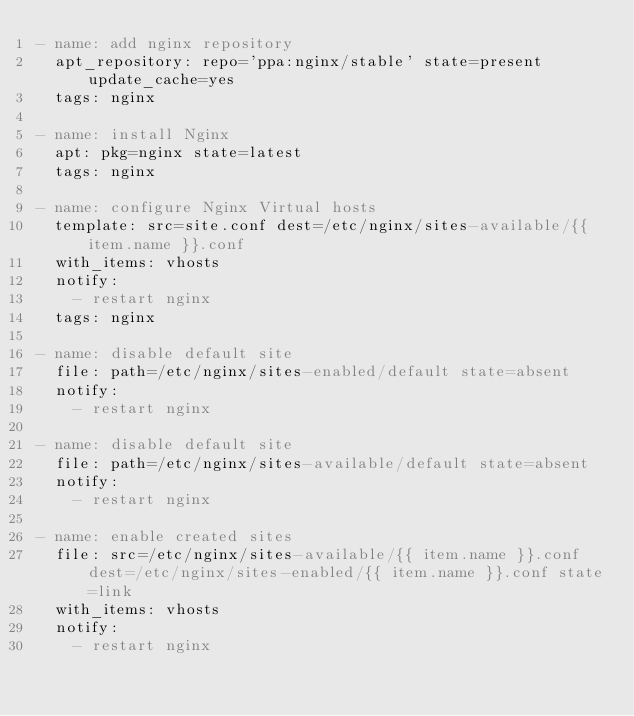Convert code to text. <code><loc_0><loc_0><loc_500><loc_500><_YAML_>- name: add nginx repository
  apt_repository: repo='ppa:nginx/stable' state=present update_cache=yes
  tags: nginx

- name: install Nginx
  apt: pkg=nginx state=latest
  tags: nginx

- name: configure Nginx Virtual hosts
  template: src=site.conf dest=/etc/nginx/sites-available/{{ item.name }}.conf
  with_items: vhosts
  notify:
    - restart nginx
  tags: nginx

- name: disable default site
  file: path=/etc/nginx/sites-enabled/default state=absent
  notify:
    - restart nginx
    
- name: disable default site
  file: path=/etc/nginx/sites-available/default state=absent
  notify:
    - restart nginx

- name: enable created sites
  file: src=/etc/nginx/sites-available/{{ item.name }}.conf dest=/etc/nginx/sites-enabled/{{ item.name }}.conf state=link
  with_items: vhosts
  notify:
    - restart nginx


</code> 